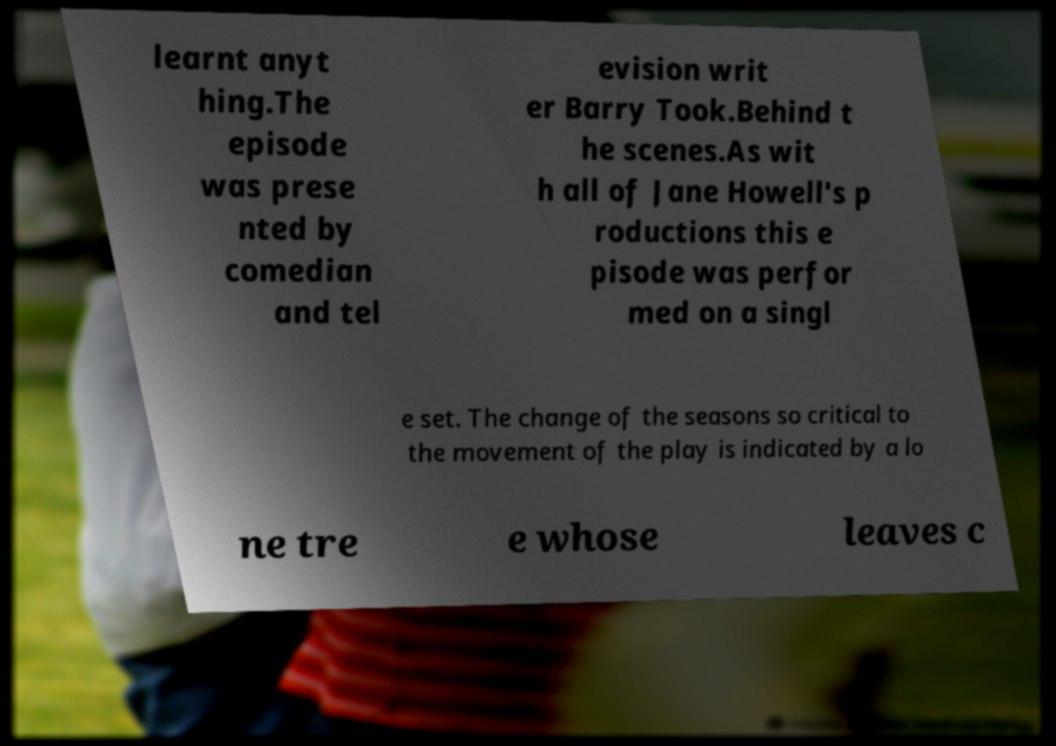Please identify and transcribe the text found in this image. learnt anyt hing.The episode was prese nted by comedian and tel evision writ er Barry Took.Behind t he scenes.As wit h all of Jane Howell's p roductions this e pisode was perfor med on a singl e set. The change of the seasons so critical to the movement of the play is indicated by a lo ne tre e whose leaves c 